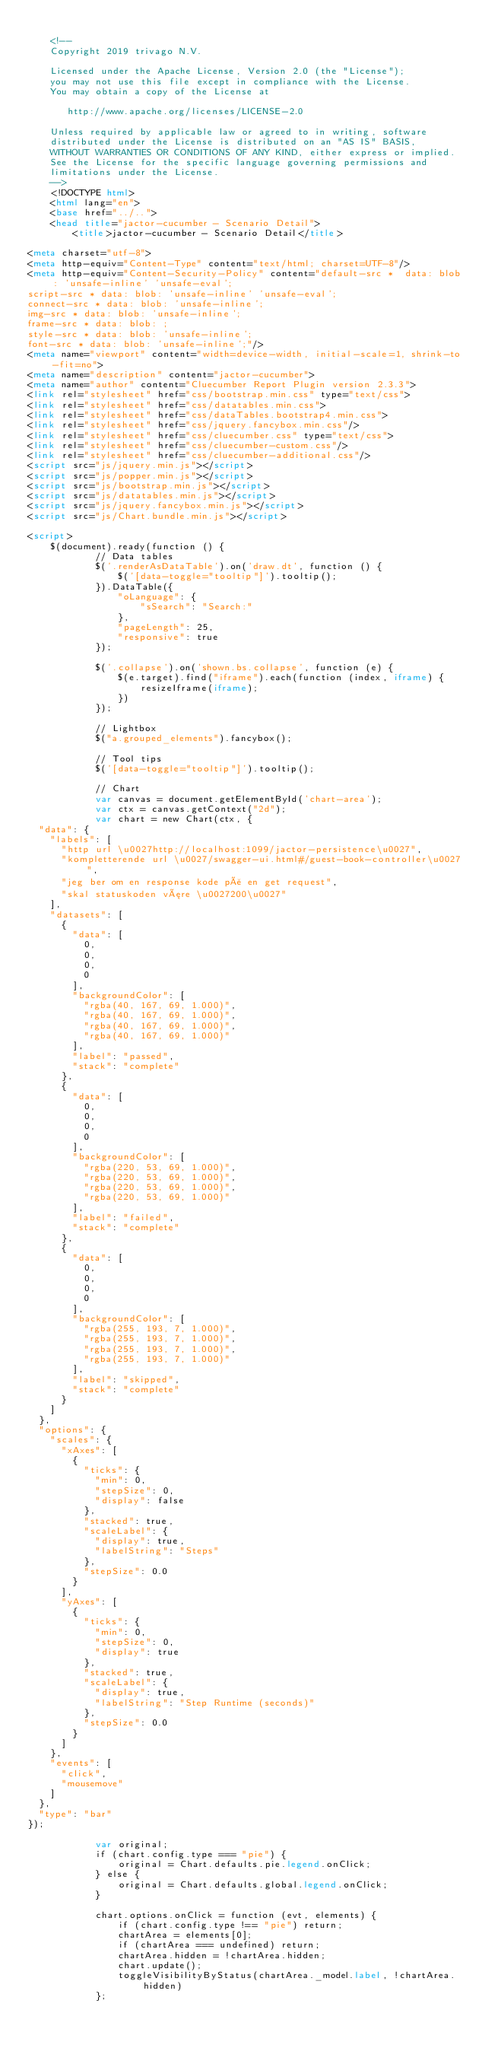Convert code to text. <code><loc_0><loc_0><loc_500><loc_500><_HTML_>
    <!--
    Copyright 2019 trivago N.V.

    Licensed under the Apache License, Version 2.0 (the "License");
    you may not use this file except in compliance with the License.
    You may obtain a copy of the License at

       http://www.apache.org/licenses/LICENSE-2.0

    Unless required by applicable law or agreed to in writing, software
    distributed under the License is distributed on an "AS IS" BASIS,
    WITHOUT WARRANTIES OR CONDITIONS OF ANY KIND, either express or implied.
    See the License for the specific language governing permissions and
    limitations under the License.
    -->
    <!DOCTYPE html>
    <html lang="en">
    <base href="../..">
    <head title="jactor-cucumber - Scenario Detail">
        <title>jactor-cucumber - Scenario Detail</title>

<meta charset="utf-8">
<meta http-equiv="Content-Type" content="text/html; charset=UTF-8"/>
<meta http-equiv="Content-Security-Policy" content="default-src *  data: blob: 'unsafe-inline' 'unsafe-eval';
script-src * data: blob: 'unsafe-inline' 'unsafe-eval';
connect-src * data: blob: 'unsafe-inline';
img-src * data: blob: 'unsafe-inline';
frame-src * data: blob: ;
style-src * data: blob: 'unsafe-inline';
font-src * data: blob: 'unsafe-inline';"/>
<meta name="viewport" content="width=device-width, initial-scale=1, shrink-to-fit=no">
<meta name="description" content="jactor-cucumber">
<meta name="author" content="Cluecumber Report Plugin version 2.3.3">
<link rel="stylesheet" href="css/bootstrap.min.css" type="text/css">
<link rel="stylesheet" href="css/datatables.min.css">
<link rel="stylesheet" href="css/dataTables.bootstrap4.min.css">
<link rel="stylesheet" href="css/jquery.fancybox.min.css"/>
<link rel="stylesheet" href="css/cluecumber.css" type="text/css">
<link rel="stylesheet" href="css/cluecumber-custom.css"/>
<link rel="stylesheet" href="css/cluecumber-additional.css"/>
<script src="js/jquery.min.js"></script>
<script src="js/popper.min.js"></script>
<script src="js/bootstrap.min.js"></script>
<script src="js/datatables.min.js"></script>
<script src="js/jquery.fancybox.min.js"></script>
<script src="js/Chart.bundle.min.js"></script>

<script>
    $(document).ready(function () {
            // Data tables
            $('.renderAsDataTable').on('draw.dt', function () {
                $('[data-toggle="tooltip"]').tooltip();
            }).DataTable({
                "oLanguage": {
                    "sSearch": "Search:"
                },
                "pageLength": 25,
                "responsive": true
            });

            $('.collapse').on('shown.bs.collapse', function (e) {
                $(e.target).find("iframe").each(function (index, iframe) {
                    resizeIframe(iframe);
                })
            });

            // Lightbox
            $("a.grouped_elements").fancybox();

            // Tool tips
            $('[data-toggle="tooltip"]').tooltip();

            // Chart
            var canvas = document.getElementById('chart-area');
            var ctx = canvas.getContext("2d");
            var chart = new Chart(ctx, {
  "data": {
    "labels": [
      "http url \u0027http://localhost:1099/jactor-persistence\u0027",
      "kompletterende url \u0027/swagger-ui.html#/guest-book-controller\u0027",
      "jeg ber om en response kode på en get request",
      "skal statuskoden være \u0027200\u0027"
    ],
    "datasets": [
      {
        "data": [
          0,
          0,
          0,
          0
        ],
        "backgroundColor": [
          "rgba(40, 167, 69, 1.000)",
          "rgba(40, 167, 69, 1.000)",
          "rgba(40, 167, 69, 1.000)",
          "rgba(40, 167, 69, 1.000)"
        ],
        "label": "passed",
        "stack": "complete"
      },
      {
        "data": [
          0,
          0,
          0,
          0
        ],
        "backgroundColor": [
          "rgba(220, 53, 69, 1.000)",
          "rgba(220, 53, 69, 1.000)",
          "rgba(220, 53, 69, 1.000)",
          "rgba(220, 53, 69, 1.000)"
        ],
        "label": "failed",
        "stack": "complete"
      },
      {
        "data": [
          0,
          0,
          0,
          0
        ],
        "backgroundColor": [
          "rgba(255, 193, 7, 1.000)",
          "rgba(255, 193, 7, 1.000)",
          "rgba(255, 193, 7, 1.000)",
          "rgba(255, 193, 7, 1.000)"
        ],
        "label": "skipped",
        "stack": "complete"
      }
    ]
  },
  "options": {
    "scales": {
      "xAxes": [
        {
          "ticks": {
            "min": 0,
            "stepSize": 0,
            "display": false
          },
          "stacked": true,
          "scaleLabel": {
            "display": true,
            "labelString": "Steps"
          },
          "stepSize": 0.0
        }
      ],
      "yAxes": [
        {
          "ticks": {
            "min": 0,
            "stepSize": 0,
            "display": true
          },
          "stacked": true,
          "scaleLabel": {
            "display": true,
            "labelString": "Step Runtime (seconds)"
          },
          "stepSize": 0.0
        }
      ]
    },
    "events": [
      "click",
      "mousemove"
    ]
  },
  "type": "bar"
});

            var original;
            if (chart.config.type === "pie") {
                original = Chart.defaults.pie.legend.onClick;
            } else {
                original = Chart.defaults.global.legend.onClick;
            }

            chart.options.onClick = function (evt, elements) {
                if (chart.config.type !== "pie") return;
                chartArea = elements[0];
                if (chartArea === undefined) return;
                chartArea.hidden = !chartArea.hidden;
                chart.update();
                toggleVisibilityByStatus(chartArea._model.label, !chartArea.hidden)
            };
</code> 